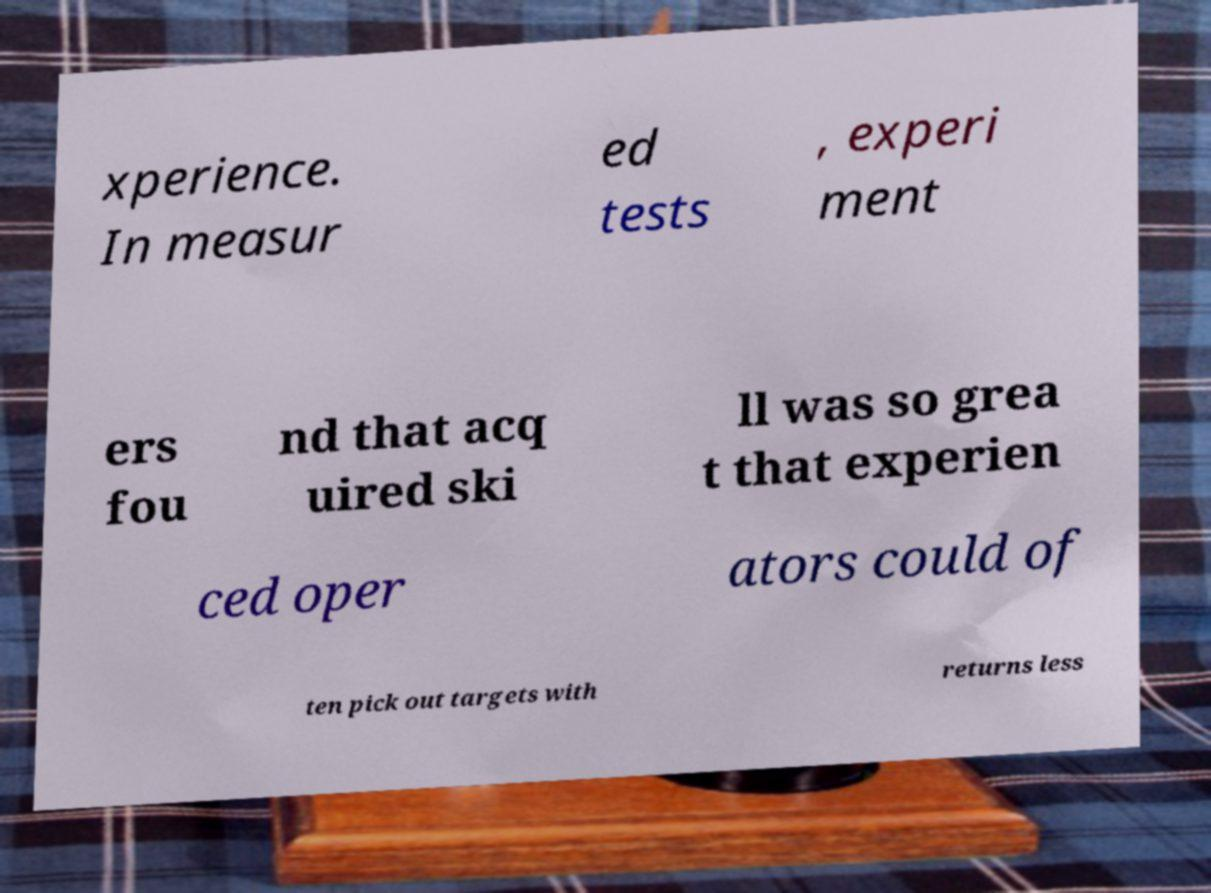There's text embedded in this image that I need extracted. Can you transcribe it verbatim? xperience. In measur ed tests , experi ment ers fou nd that acq uired ski ll was so grea t that experien ced oper ators could of ten pick out targets with returns less 